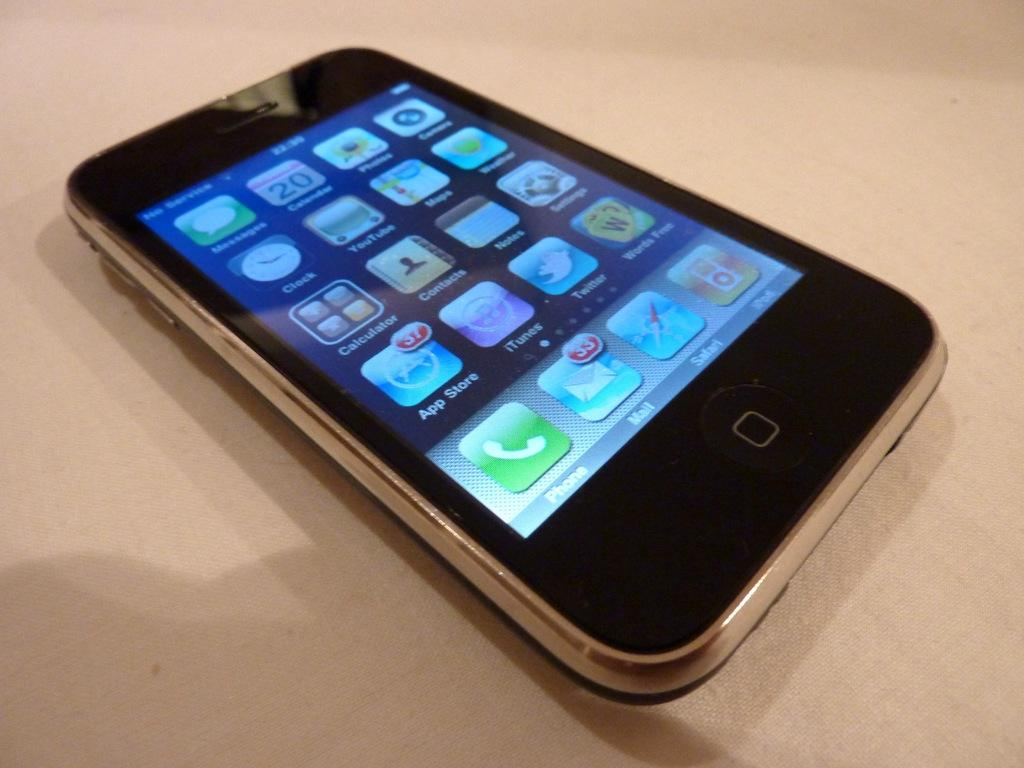Provide a one-sentence caption for the provided image. An iphone with several apps, the second from top left having the number 20. 